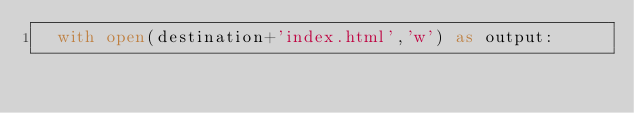Convert code to text. <code><loc_0><loc_0><loc_500><loc_500><_Python_>	with open(destination+'index.html','w') as output:
		
 	</code> 